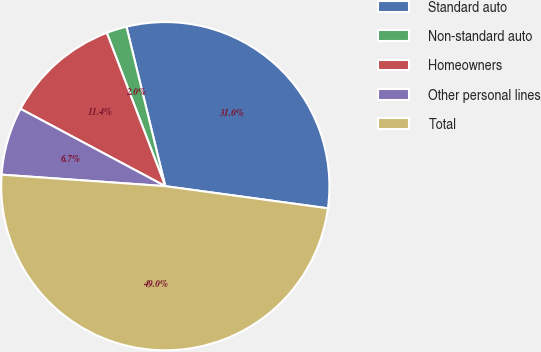<chart> <loc_0><loc_0><loc_500><loc_500><pie_chart><fcel>Standard auto<fcel>Non-standard auto<fcel>Homeowners<fcel>Other personal lines<fcel>Total<nl><fcel>30.95%<fcel>2.0%<fcel>11.39%<fcel>6.69%<fcel>48.96%<nl></chart> 